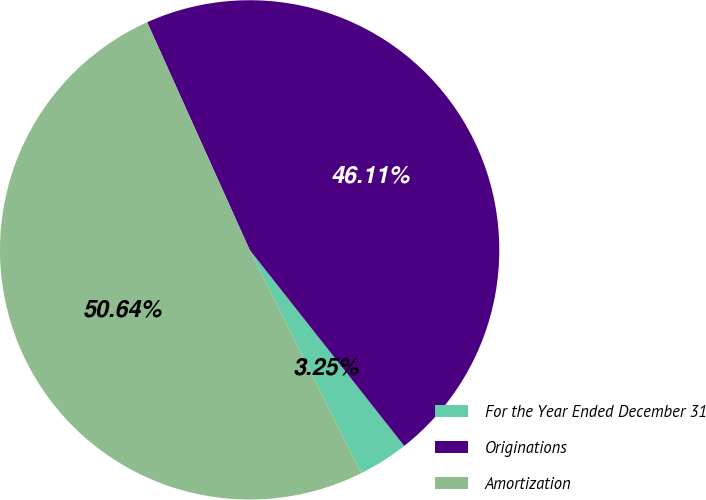Convert chart. <chart><loc_0><loc_0><loc_500><loc_500><pie_chart><fcel>For the Year Ended December 31<fcel>Originations<fcel>Amortization<nl><fcel>3.25%<fcel>46.11%<fcel>50.65%<nl></chart> 